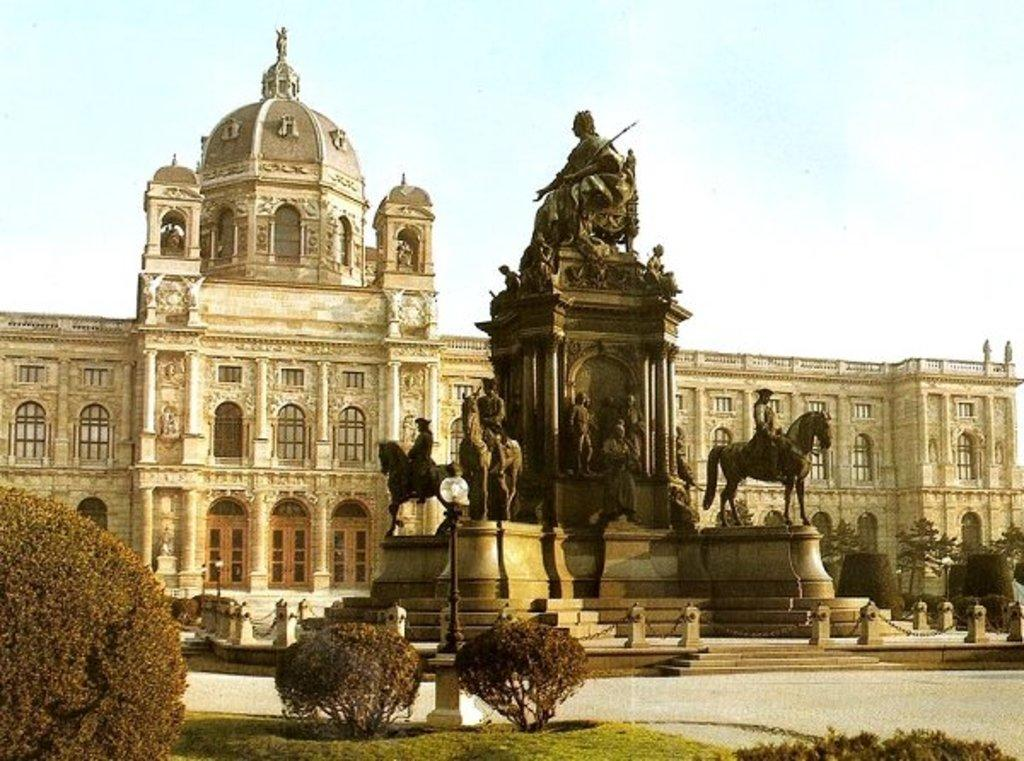What type of vegetation is at the bottom of the image? There are bushes at the bottom of the image. What can be seen in the middle of the image? There are statues in the middle of the image. What structure is located at the back side of the image? There is a fort at the back side of the image. What is visible at the top of the image? The sky is visible at the top of the image. What type of locket is hanging from the statue in the image? There is no locket present on the statues in the image. Are there any jeans visible in the image? There are no jeans present in the image. 